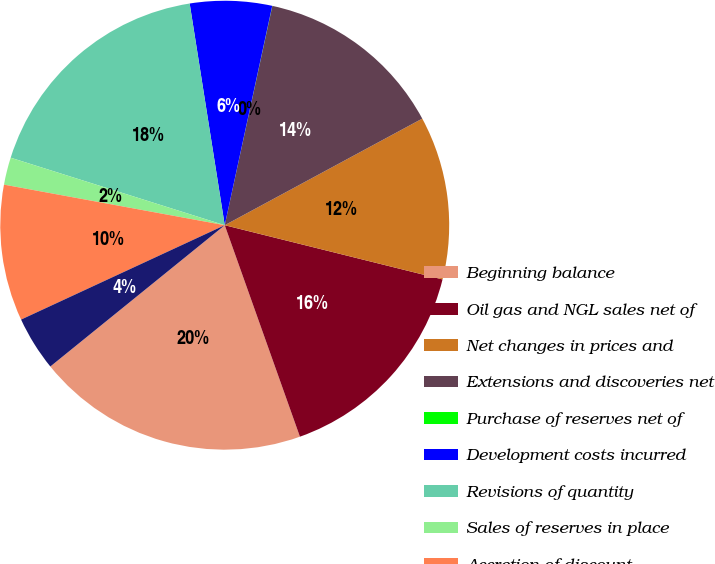Convert chart. <chart><loc_0><loc_0><loc_500><loc_500><pie_chart><fcel>Beginning balance<fcel>Oil gas and NGL sales net of<fcel>Net changes in prices and<fcel>Extensions and discoveries net<fcel>Purchase of reserves net of<fcel>Development costs incurred<fcel>Revisions of quantity<fcel>Sales of reserves in place<fcel>Accretion of discount<fcel>Net change in income taxes<nl><fcel>19.6%<fcel>15.68%<fcel>11.76%<fcel>13.72%<fcel>0.01%<fcel>5.89%<fcel>17.64%<fcel>1.97%<fcel>9.8%<fcel>3.93%<nl></chart> 